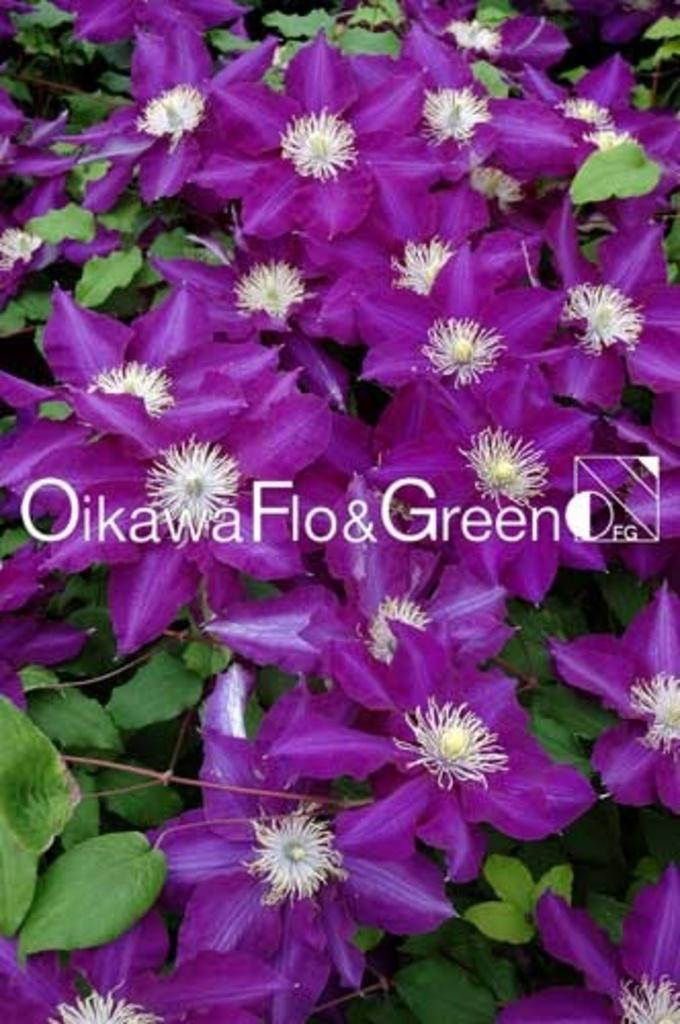What type of plants can be seen in the image? There are flowers and leaves in the image. Can you describe the appearance of the flowers? Unfortunately, the specific appearance of the flowers cannot be determined from the provided facts. Is there any indication of the image's origin or ownership? Yes, there is a watermark on the image. How many prisoners are visible in the image? There are no prisoners present in the image; it features flowers and leaves. What type of punishment is being administered to the frogs in the image? There are no frogs or any indication of punishment in the image. 